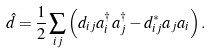<formula> <loc_0><loc_0><loc_500><loc_500>\hat { d } = \frac { 1 } { 2 } \sum _ { i j } \left ( d _ { i j } a _ { i } ^ { \dagger } a _ { j } ^ { \dagger } - d _ { i j } ^ { * } a _ { j } a _ { i } \right ) .</formula> 